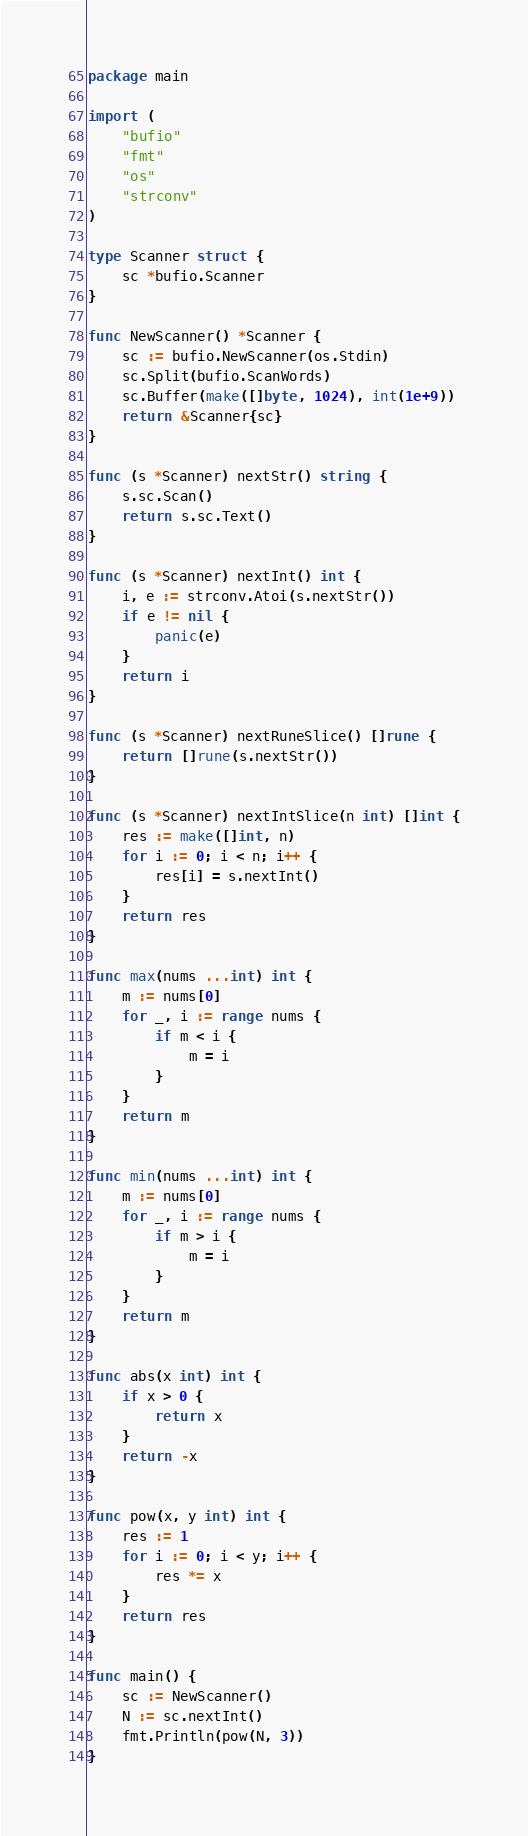Convert code to text. <code><loc_0><loc_0><loc_500><loc_500><_Go_>package main

import (
	"bufio"
	"fmt"
	"os"
	"strconv"
)

type Scanner struct {
	sc *bufio.Scanner
}

func NewScanner() *Scanner {
	sc := bufio.NewScanner(os.Stdin)
	sc.Split(bufio.ScanWords)
	sc.Buffer(make([]byte, 1024), int(1e+9))
	return &Scanner{sc}
}

func (s *Scanner) nextStr() string {
	s.sc.Scan()
	return s.sc.Text()
}

func (s *Scanner) nextInt() int {
	i, e := strconv.Atoi(s.nextStr())
	if e != nil {
		panic(e)
	}
	return i
}

func (s *Scanner) nextRuneSlice() []rune {
	return []rune(s.nextStr())
}

func (s *Scanner) nextIntSlice(n int) []int {
	res := make([]int, n)
	for i := 0; i < n; i++ {
		res[i] = s.nextInt()
	}
	return res
}

func max(nums ...int) int {
	m := nums[0]
	for _, i := range nums {
		if m < i {
			m = i
		}
	}
	return m
}

func min(nums ...int) int {
	m := nums[0]
	for _, i := range nums {
		if m > i {
			m = i
		}
	}
	return m
}

func abs(x int) int {
	if x > 0 {
		return x
	}
	return -x
}

func pow(x, y int) int {
	res := 1
	for i := 0; i < y; i++ {
		res *= x
	}
	return res
}

func main() {
	sc := NewScanner()
	N := sc.nextInt()
	fmt.Println(pow(N, 3))
}
</code> 